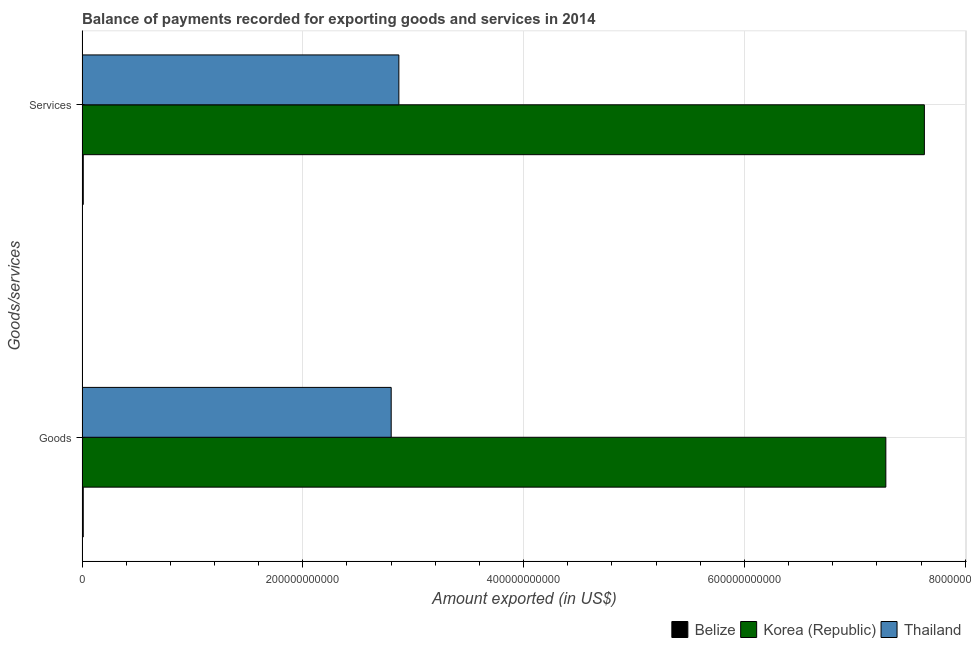Are the number of bars per tick equal to the number of legend labels?
Your answer should be very brief. Yes. Are the number of bars on each tick of the Y-axis equal?
Offer a terse response. Yes. How many bars are there on the 1st tick from the bottom?
Offer a very short reply. 3. What is the label of the 1st group of bars from the top?
Offer a terse response. Services. What is the amount of goods exported in Belize?
Provide a short and direct response. 1.08e+09. Across all countries, what is the maximum amount of services exported?
Provide a short and direct response. 7.63e+11. Across all countries, what is the minimum amount of services exported?
Your answer should be compact. 1.09e+09. In which country was the amount of goods exported maximum?
Your answer should be compact. Korea (Republic). In which country was the amount of goods exported minimum?
Give a very brief answer. Belize. What is the total amount of goods exported in the graph?
Your response must be concise. 1.01e+12. What is the difference between the amount of goods exported in Korea (Republic) and that in Thailand?
Offer a terse response. 4.48e+11. What is the difference between the amount of services exported in Thailand and the amount of goods exported in Belize?
Offer a very short reply. 2.86e+11. What is the average amount of services exported per country?
Offer a terse response. 3.50e+11. What is the difference between the amount of goods exported and amount of services exported in Korea (Republic)?
Offer a terse response. -3.49e+1. In how many countries, is the amount of goods exported greater than 240000000000 US$?
Offer a very short reply. 2. What is the ratio of the amount of goods exported in Belize to that in Thailand?
Your answer should be very brief. 0. What does the 2nd bar from the top in Goods represents?
Your answer should be very brief. Korea (Republic). What does the 3rd bar from the bottom in Goods represents?
Keep it short and to the point. Thailand. Are all the bars in the graph horizontal?
Offer a very short reply. Yes. What is the difference between two consecutive major ticks on the X-axis?
Offer a terse response. 2.00e+11. How many legend labels are there?
Your answer should be compact. 3. What is the title of the graph?
Your answer should be compact. Balance of payments recorded for exporting goods and services in 2014. Does "Kenya" appear as one of the legend labels in the graph?
Ensure brevity in your answer.  No. What is the label or title of the X-axis?
Give a very brief answer. Amount exported (in US$). What is the label or title of the Y-axis?
Keep it short and to the point. Goods/services. What is the Amount exported (in US$) in Belize in Goods?
Your answer should be compact. 1.08e+09. What is the Amount exported (in US$) in Korea (Republic) in Goods?
Keep it short and to the point. 7.28e+11. What is the Amount exported (in US$) in Thailand in Goods?
Your answer should be compact. 2.80e+11. What is the Amount exported (in US$) of Belize in Services?
Make the answer very short. 1.09e+09. What is the Amount exported (in US$) of Korea (Republic) in Services?
Offer a terse response. 7.63e+11. What is the Amount exported (in US$) in Thailand in Services?
Your answer should be very brief. 2.87e+11. Across all Goods/services, what is the maximum Amount exported (in US$) of Belize?
Provide a short and direct response. 1.09e+09. Across all Goods/services, what is the maximum Amount exported (in US$) of Korea (Republic)?
Provide a succinct answer. 7.63e+11. Across all Goods/services, what is the maximum Amount exported (in US$) in Thailand?
Keep it short and to the point. 2.87e+11. Across all Goods/services, what is the minimum Amount exported (in US$) of Belize?
Your answer should be very brief. 1.08e+09. Across all Goods/services, what is the minimum Amount exported (in US$) in Korea (Republic)?
Keep it short and to the point. 7.28e+11. Across all Goods/services, what is the minimum Amount exported (in US$) of Thailand?
Provide a short and direct response. 2.80e+11. What is the total Amount exported (in US$) in Belize in the graph?
Offer a very short reply. 2.17e+09. What is the total Amount exported (in US$) of Korea (Republic) in the graph?
Provide a succinct answer. 1.49e+12. What is the total Amount exported (in US$) of Thailand in the graph?
Your answer should be compact. 5.67e+11. What is the difference between the Amount exported (in US$) in Belize in Goods and that in Services?
Your response must be concise. -8.43e+06. What is the difference between the Amount exported (in US$) in Korea (Republic) in Goods and that in Services?
Offer a very short reply. -3.49e+1. What is the difference between the Amount exported (in US$) in Thailand in Goods and that in Services?
Your answer should be very brief. -6.95e+09. What is the difference between the Amount exported (in US$) of Belize in Goods and the Amount exported (in US$) of Korea (Republic) in Services?
Offer a very short reply. -7.62e+11. What is the difference between the Amount exported (in US$) of Belize in Goods and the Amount exported (in US$) of Thailand in Services?
Provide a short and direct response. -2.86e+11. What is the difference between the Amount exported (in US$) of Korea (Republic) in Goods and the Amount exported (in US$) of Thailand in Services?
Your response must be concise. 4.41e+11. What is the average Amount exported (in US$) in Belize per Goods/services?
Your answer should be very brief. 1.09e+09. What is the average Amount exported (in US$) in Korea (Republic) per Goods/services?
Provide a succinct answer. 7.46e+11. What is the average Amount exported (in US$) of Thailand per Goods/services?
Offer a very short reply. 2.84e+11. What is the difference between the Amount exported (in US$) of Belize and Amount exported (in US$) of Korea (Republic) in Goods?
Give a very brief answer. -7.27e+11. What is the difference between the Amount exported (in US$) of Belize and Amount exported (in US$) of Thailand in Goods?
Make the answer very short. -2.79e+11. What is the difference between the Amount exported (in US$) in Korea (Republic) and Amount exported (in US$) in Thailand in Goods?
Keep it short and to the point. 4.48e+11. What is the difference between the Amount exported (in US$) in Belize and Amount exported (in US$) in Korea (Republic) in Services?
Provide a short and direct response. -7.62e+11. What is the difference between the Amount exported (in US$) of Belize and Amount exported (in US$) of Thailand in Services?
Your response must be concise. -2.86e+11. What is the difference between the Amount exported (in US$) of Korea (Republic) and Amount exported (in US$) of Thailand in Services?
Give a very brief answer. 4.76e+11. What is the ratio of the Amount exported (in US$) in Belize in Goods to that in Services?
Your response must be concise. 0.99. What is the ratio of the Amount exported (in US$) of Korea (Republic) in Goods to that in Services?
Your response must be concise. 0.95. What is the ratio of the Amount exported (in US$) in Thailand in Goods to that in Services?
Offer a very short reply. 0.98. What is the difference between the highest and the second highest Amount exported (in US$) in Belize?
Your answer should be very brief. 8.43e+06. What is the difference between the highest and the second highest Amount exported (in US$) in Korea (Republic)?
Provide a short and direct response. 3.49e+1. What is the difference between the highest and the second highest Amount exported (in US$) in Thailand?
Provide a succinct answer. 6.95e+09. What is the difference between the highest and the lowest Amount exported (in US$) of Belize?
Provide a short and direct response. 8.43e+06. What is the difference between the highest and the lowest Amount exported (in US$) of Korea (Republic)?
Ensure brevity in your answer.  3.49e+1. What is the difference between the highest and the lowest Amount exported (in US$) of Thailand?
Your answer should be compact. 6.95e+09. 